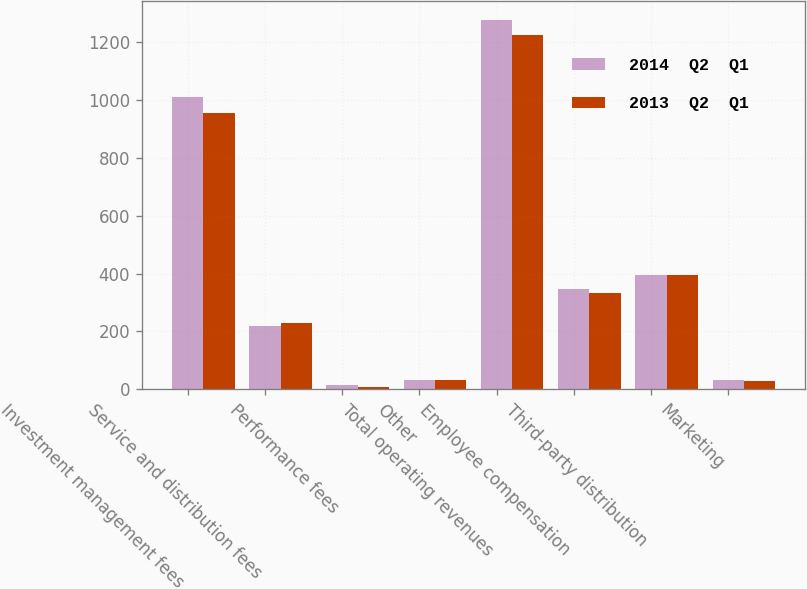Convert chart. <chart><loc_0><loc_0><loc_500><loc_500><stacked_bar_chart><ecel><fcel>Investment management fees<fcel>Service and distribution fees<fcel>Performance fees<fcel>Other<fcel>Total operating revenues<fcel>Employee compensation<fcel>Third-party distribution<fcel>Marketing<nl><fcel>2014  Q2  Q1<fcel>1009.5<fcel>217.7<fcel>16.8<fcel>32.7<fcel>1276.7<fcel>345.7<fcel>394.5<fcel>31.9<nl><fcel>2013  Q2  Q1<fcel>955.1<fcel>230.1<fcel>8.7<fcel>31.2<fcel>1225.1<fcel>333.4<fcel>396.2<fcel>30<nl></chart> 